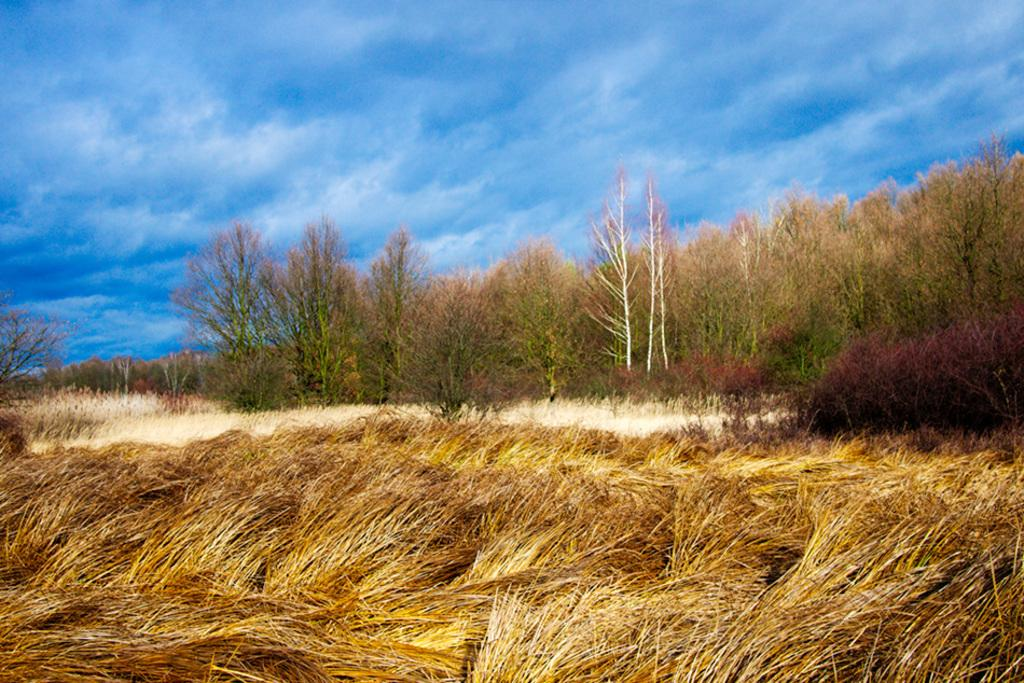What is located in the center of the image? There are trees, plants, grass, the sky, and clouds in the center of the image. Can you describe the vegetation in the center of the image? There are trees and plants in the center of the image. What type of ground cover is present in the center of the image? There is grass in the center of the image. What can be seen in the sky in the center of the image? The sky and clouds are visible in the center of the image. What type of bat is flying in the center of the image? There is no bat present in the image; it features trees, plants, grass, sky, and clouds. What kind of stitch is used to create the clouds in the center of the image? The clouds in the image are not created using stitches; they are natural formations in the sky. 